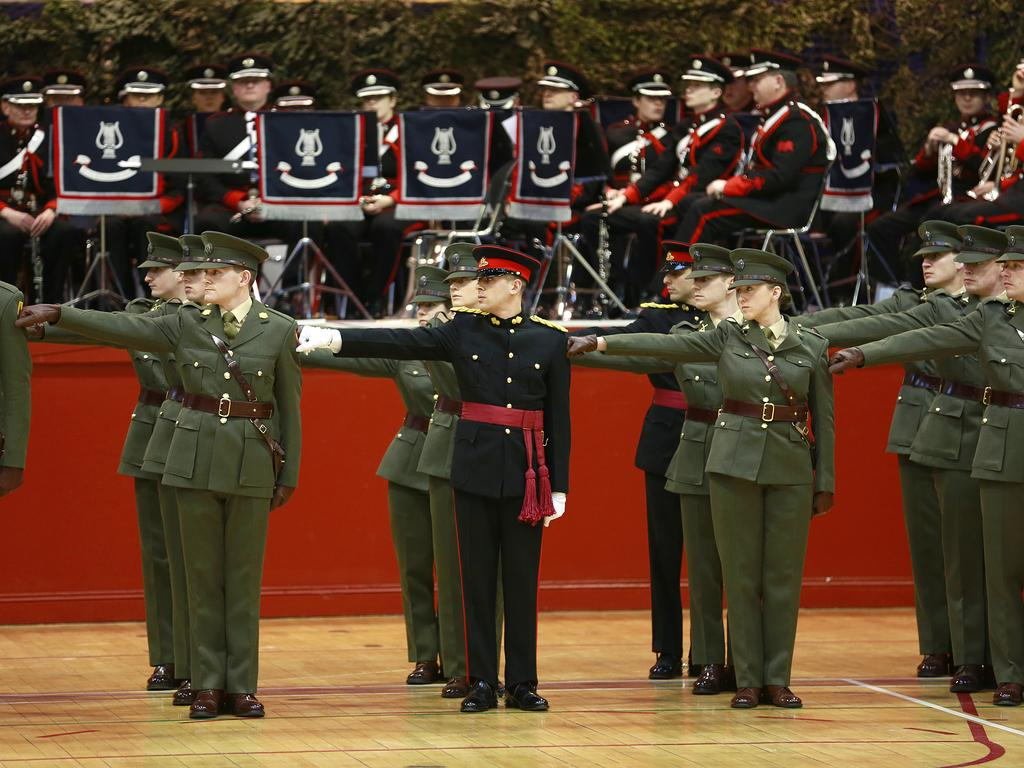What activity are the army personnel engaged in within the image? The army personnel are performing a parade in the image. Are there any other army personnel in the image who are not participating in the parade? Yes, there are other army personnel seated on chairs in the image. What can be seen in the background of the image? Trees are visible in the background of the image. What type of stew is being served to the army personnel during their discussion in the image? There is no stew or discussion present in the image; it features army personnel performing a parade and others seated on chairs. What need is being addressed by the army personnel during their discussion in the image? There is no discussion taking place in the image, so it is not possible to determine what need might be addressed. 